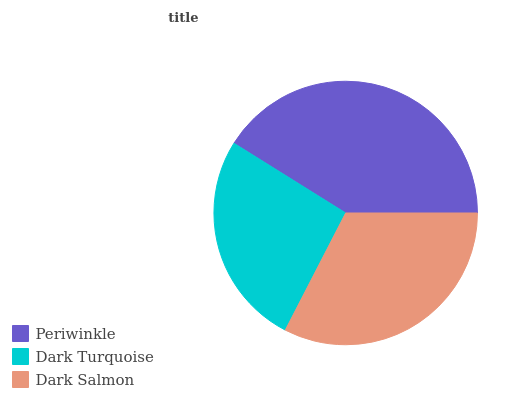Is Dark Turquoise the minimum?
Answer yes or no. Yes. Is Periwinkle the maximum?
Answer yes or no. Yes. Is Dark Salmon the minimum?
Answer yes or no. No. Is Dark Salmon the maximum?
Answer yes or no. No. Is Dark Salmon greater than Dark Turquoise?
Answer yes or no. Yes. Is Dark Turquoise less than Dark Salmon?
Answer yes or no. Yes. Is Dark Turquoise greater than Dark Salmon?
Answer yes or no. No. Is Dark Salmon less than Dark Turquoise?
Answer yes or no. No. Is Dark Salmon the high median?
Answer yes or no. Yes. Is Dark Salmon the low median?
Answer yes or no. Yes. Is Dark Turquoise the high median?
Answer yes or no. No. Is Dark Turquoise the low median?
Answer yes or no. No. 